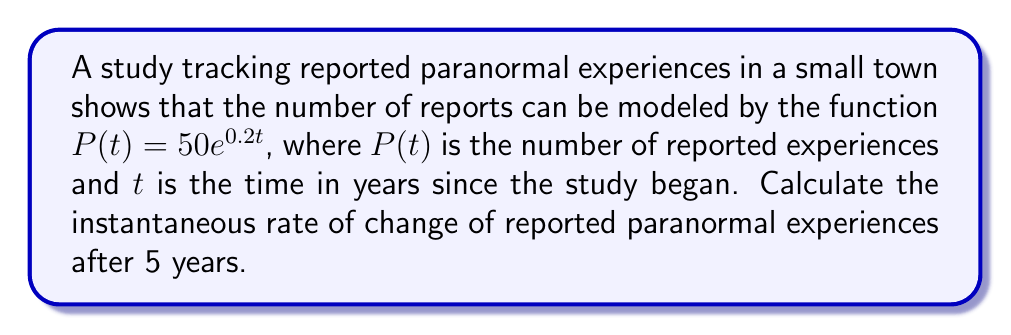Give your solution to this math problem. To find the instantaneous rate of change, we need to calculate the derivative of the function $P(t)$ and evaluate it at $t=5$.

1) The given function is $P(t) = 50e^{0.2t}$

2) To find the derivative, we use the chain rule:
   $$\frac{d}{dt}P(t) = 50 \cdot \frac{d}{dt}(e^{0.2t}) = 50 \cdot 0.2e^{0.2t} = 10e^{0.2t}$$

3) This derivative represents the instantaneous rate of change at any time $t$.

4) To find the rate of change at $t=5$, we substitute $t=5$ into the derivative:
   $$\frac{d}{dt}P(5) = 10e^{0.2(5)} = 10e^1 = 10e \approx 27.18$$

5) Therefore, after 5 years, the instantaneous rate of change of reported paranormal experiences is approximately 27.18 reports per year.
Answer: $10e$ reports/year $\approx 27.18$ reports/year 